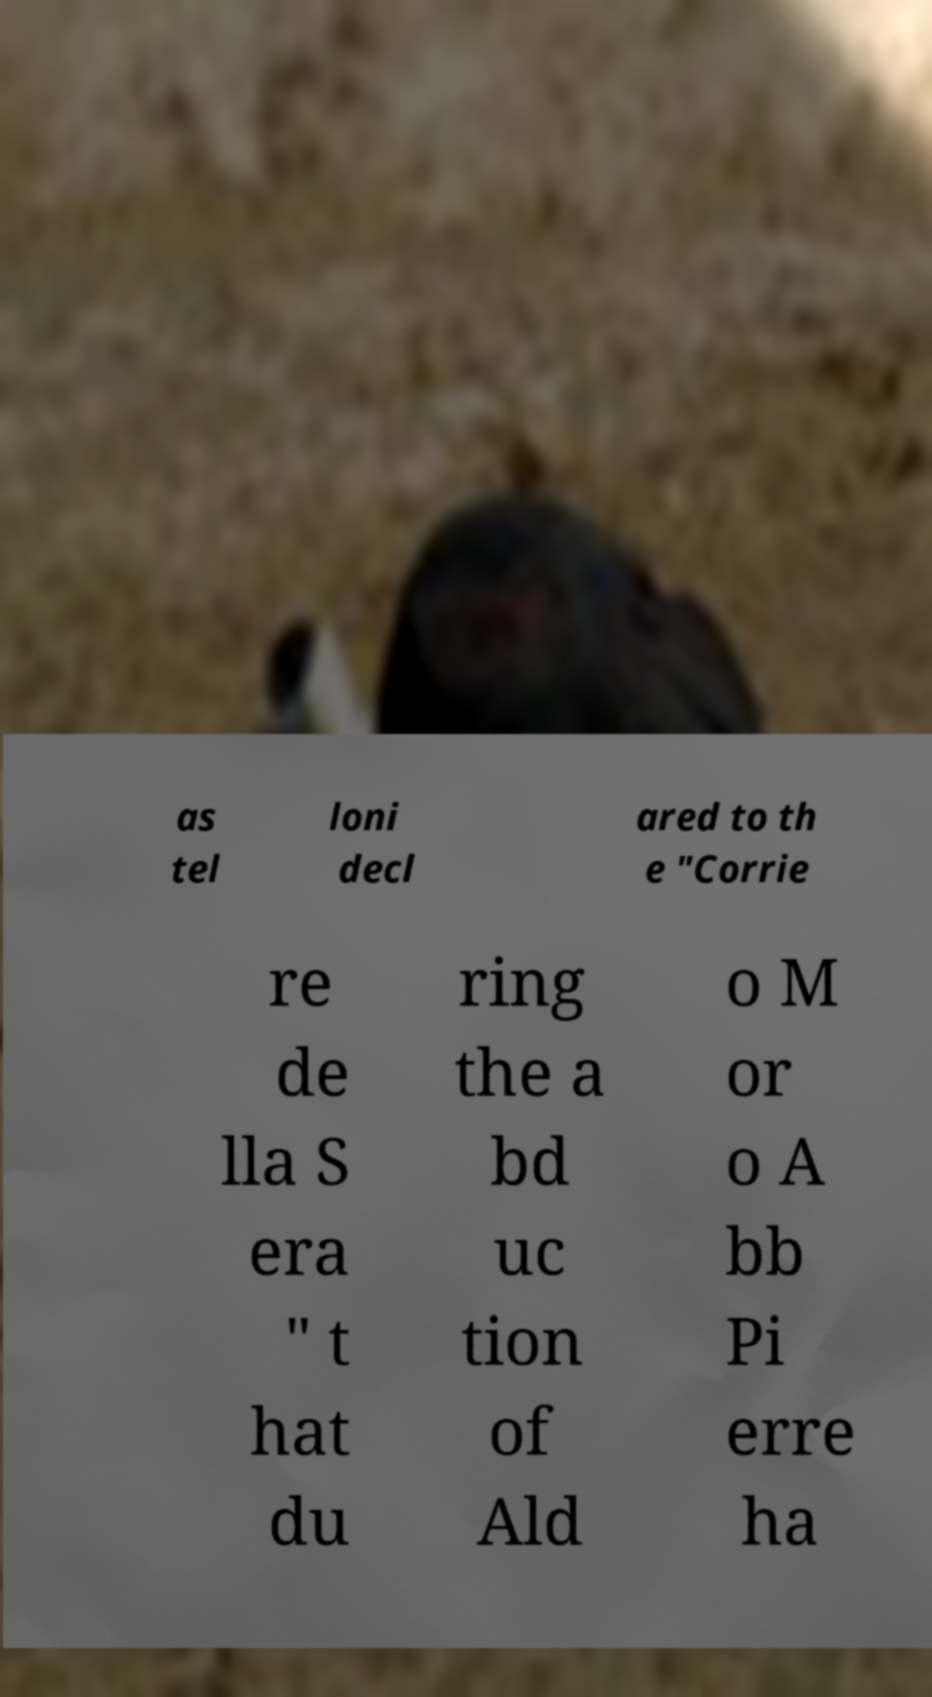For documentation purposes, I need the text within this image transcribed. Could you provide that? as tel loni decl ared to th e "Corrie re de lla S era " t hat du ring the a bd uc tion of Ald o M or o A bb Pi erre ha 